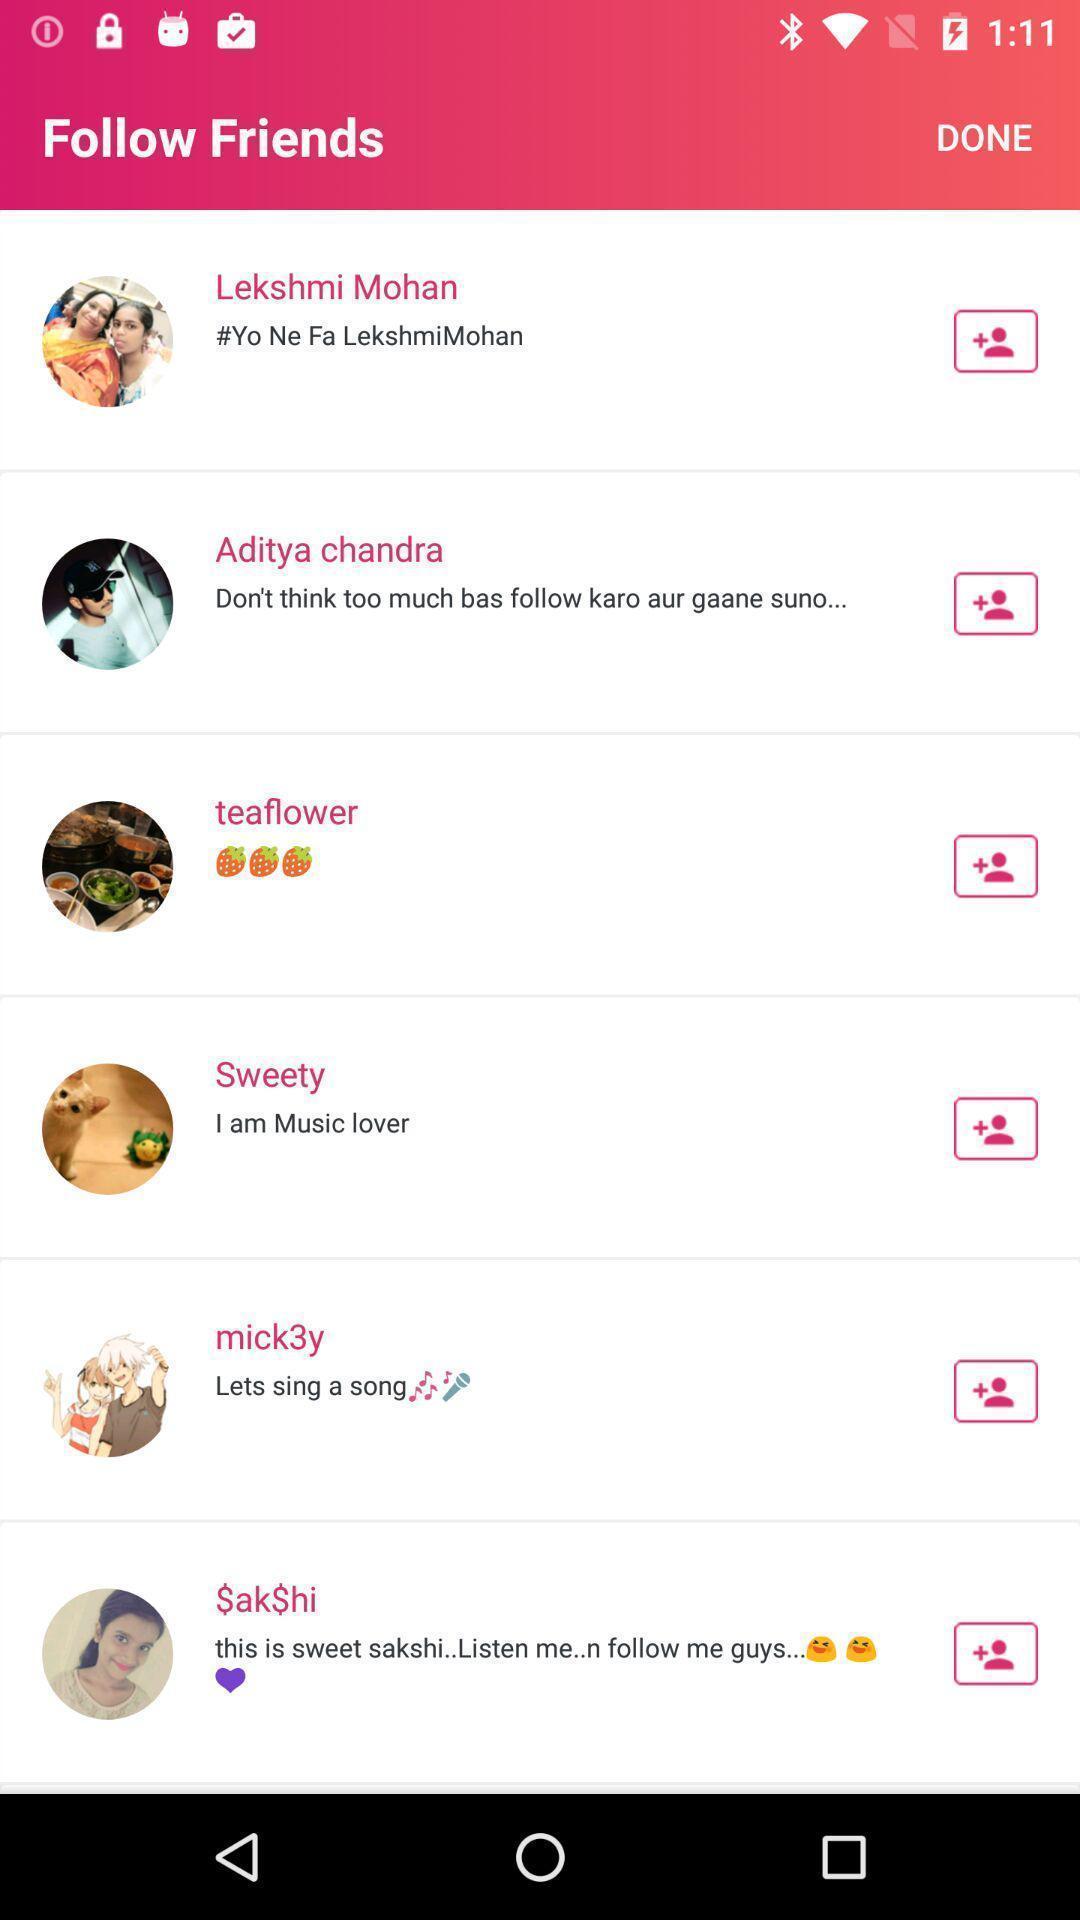What details can you identify in this image? Screen shows friends list in music collaboration app. 